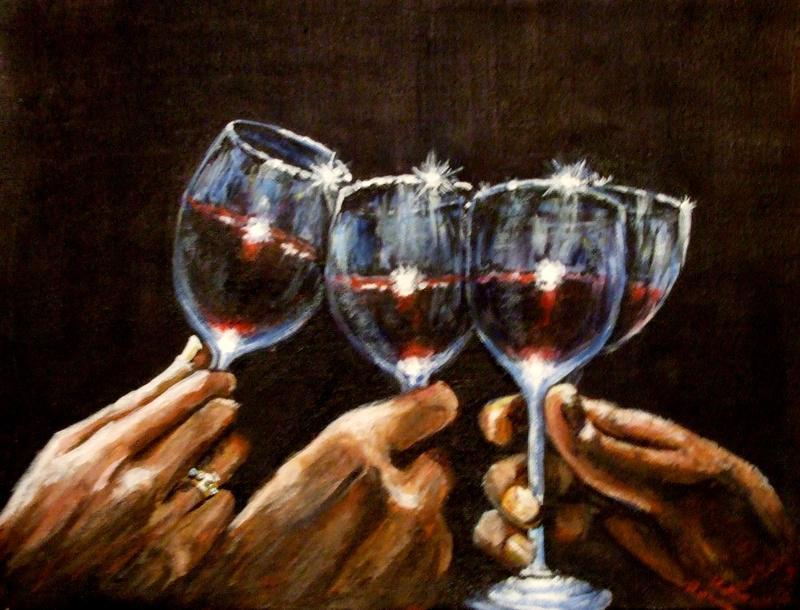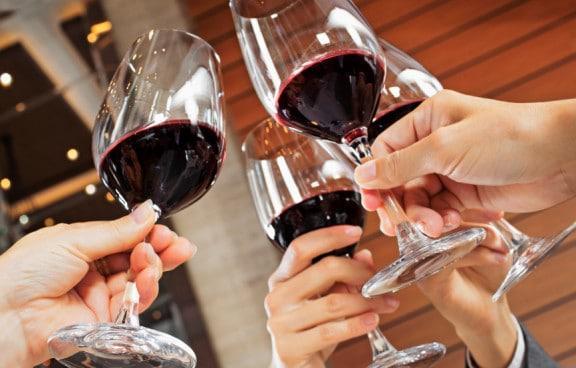The first image is the image on the left, the second image is the image on the right. Considering the images on both sides, is "No hands are holding the wine glasses in the right-hand image." valid? Answer yes or no. No. The first image is the image on the left, the second image is the image on the right. Assess this claim about the two images: "At least one image has a flame or candle in the background.". Correct or not? Answer yes or no. No. 